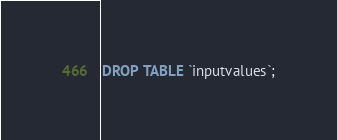<code> <loc_0><loc_0><loc_500><loc_500><_SQL_>DROP TABLE `inputvalues`;
</code> 